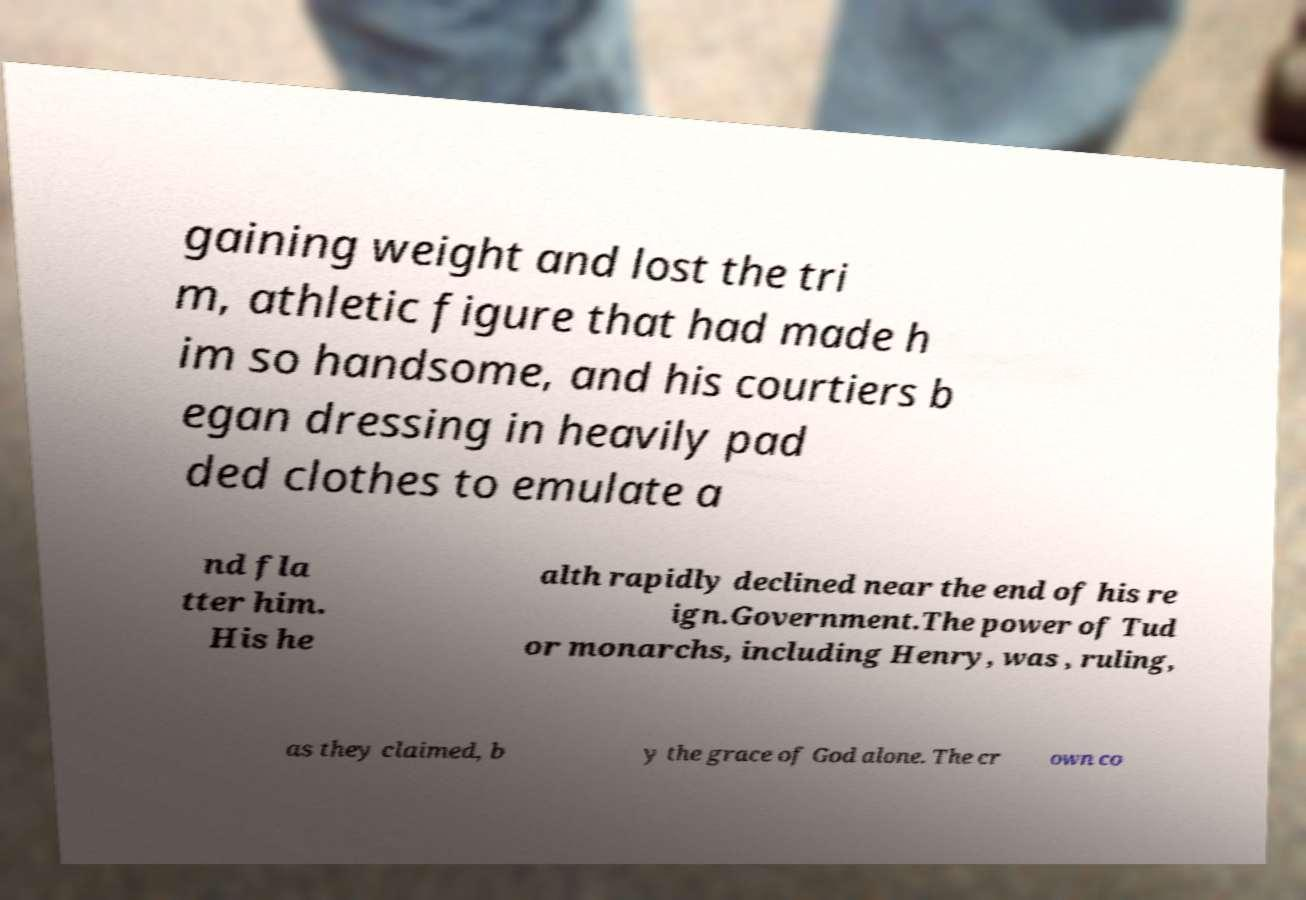Can you read and provide the text displayed in the image?This photo seems to have some interesting text. Can you extract and type it out for me? gaining weight and lost the tri m, athletic figure that had made h im so handsome, and his courtiers b egan dressing in heavily pad ded clothes to emulate a nd fla tter him. His he alth rapidly declined near the end of his re ign.Government.The power of Tud or monarchs, including Henry, was , ruling, as they claimed, b y the grace of God alone. The cr own co 